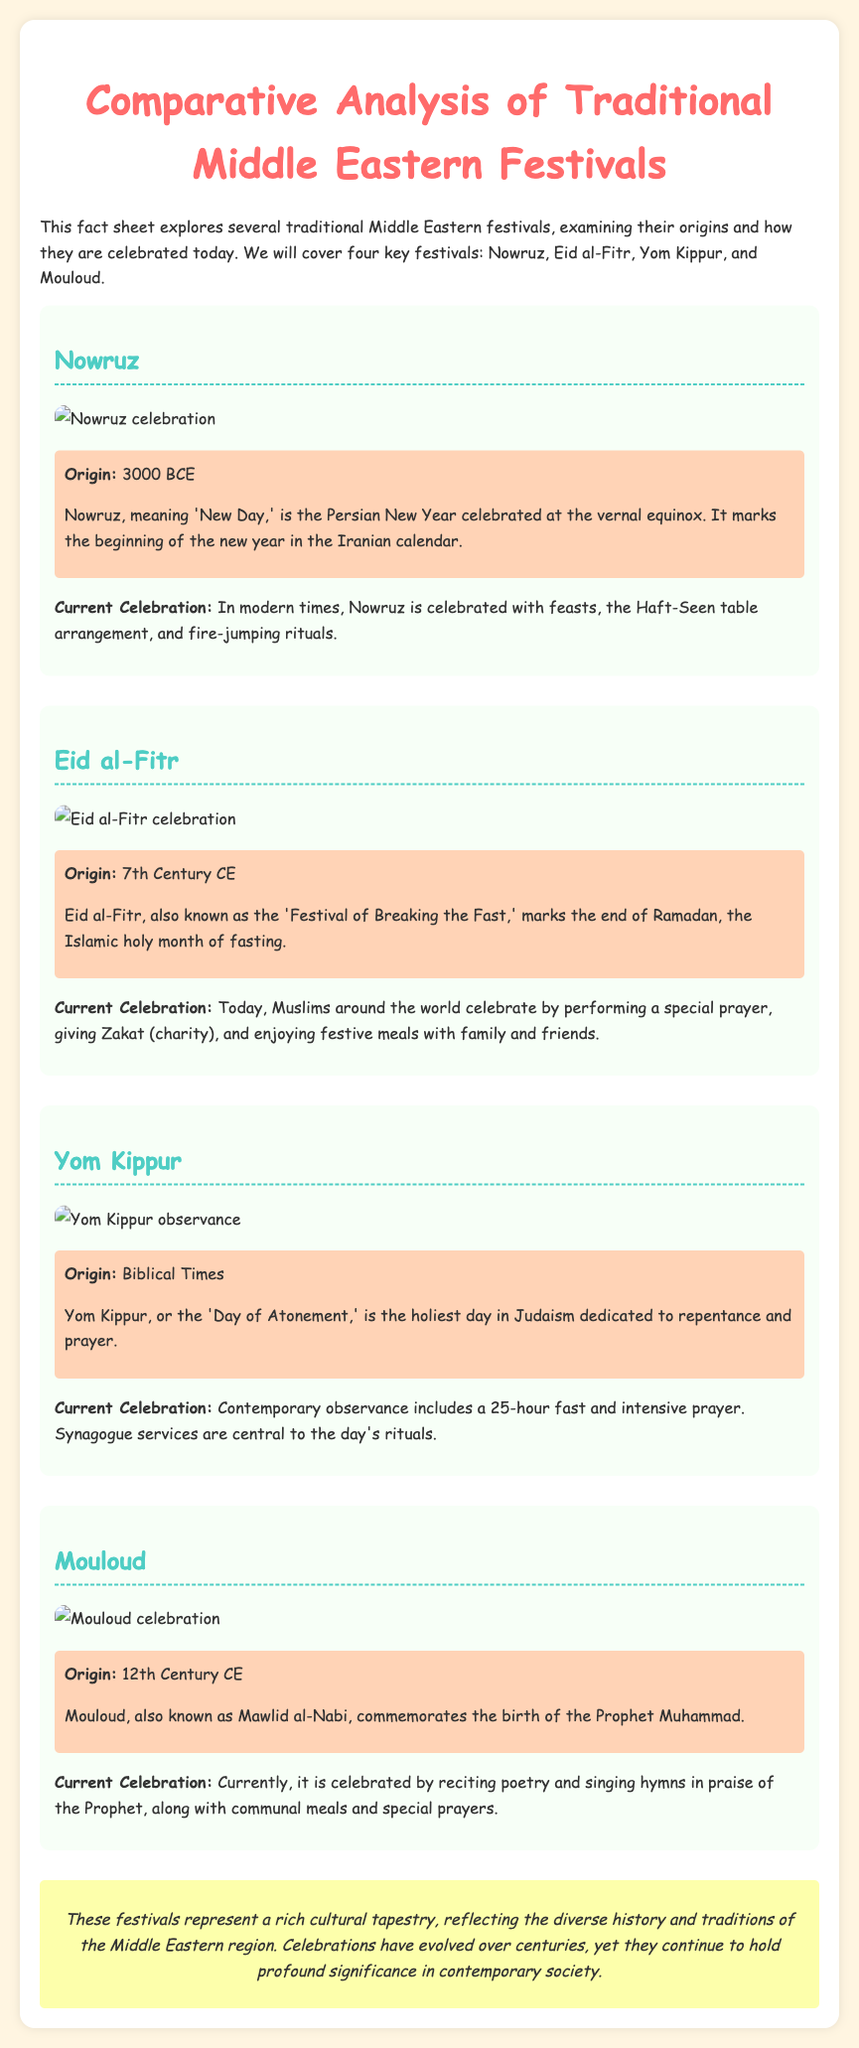What does Nowruz mean? Nowruz means 'New Day' and is the Persian New Year celebrated at the vernal equinox.
Answer: New Day When does Nowruz originate? Nowruz originated in 3000 BCE, marking the beginning of a new year in the Iranian calendar.
Answer: 3000 BCE What is Eid al-Fitr also known as? Eid al-Fitr is also known as the 'Festival of Breaking the Fast'.
Answer: Festival of Breaking the Fast What is the current celebration of Yom Kippur focused on? The current celebration of Yom Kippur focuses on a 25-hour fast and intensive prayer at synagogue services.
Answer: Prayer Which festival commemorates the birth of the Prophet Muhammad? Mouloud, also known as Mawlid al-Nabi, commemorates the birth of the Prophet Muhammad.
Answer: Mouloud What cultural aspect is highlighted in the conclusion? The conclusion highlights that these festivals represent a rich cultural tapestry reflecting diverse history and traditions.
Answer: Cultural tapestry How many main festivals are discussed in the fact sheet? The fact sheet covers four key festivals: Nowruz, Eid al-Fitr, Yom Kippur, and Mouloud.
Answer: Four What type of information do the timelines provide? The timelines provide the origins of each festival.
Answer: Origins What type of document is this? This document is a fact sheet exploring traditional Middle Eastern festivals.
Answer: Fact sheet 